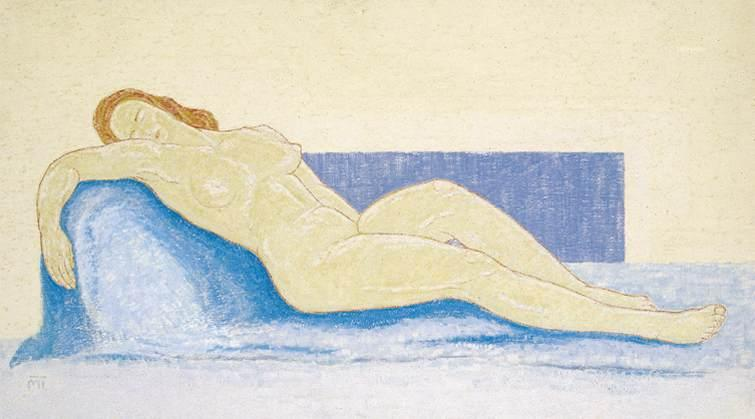What do you think the artist was trying to convey through the composition and the choice of colors in this artwork? The artist seems to be exploring themes of tranquility and natural beauty, utilizing a minimalistic color scheme to emphasize the subject's form and emotional state. The use of a soft yellow background and a distinct blue couch not only creates a striking contrast but also enhances the contemplative mood. The composition, with the figure aligned diagonally across the canvas, draws the viewer's eye along her form, enhancing the feel of depth and the introspective quality of the piece. 